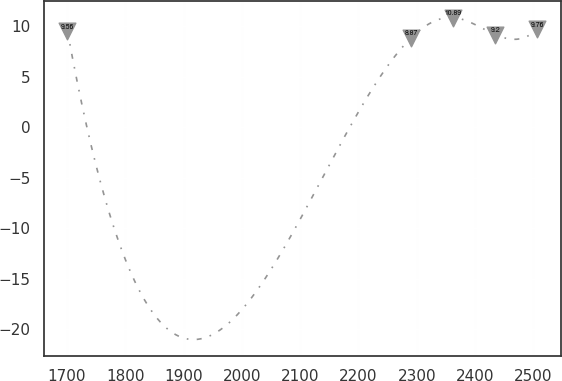<chart> <loc_0><loc_0><loc_500><loc_500><line_chart><ecel><fcel>Unnamed: 1<nl><fcel>1700.91<fcel>9.56<nl><fcel>2290.43<fcel>8.87<nl><fcel>2362.59<fcel>10.89<nl><fcel>2434.75<fcel>9.2<nl><fcel>2506.91<fcel>9.76<nl></chart> 